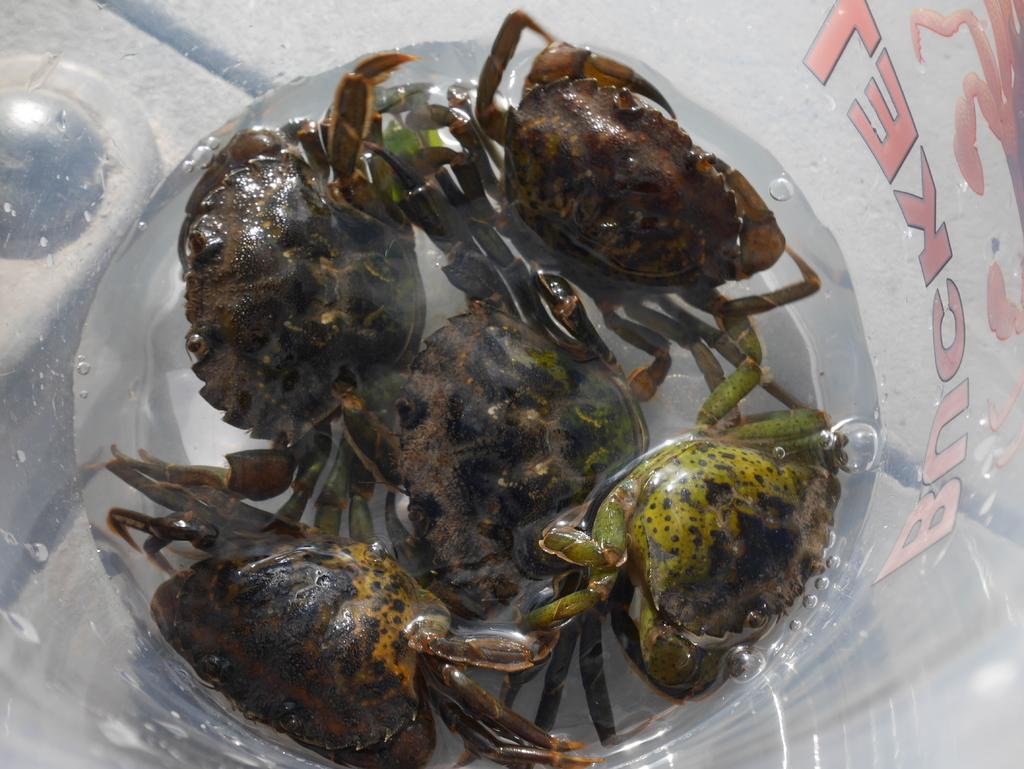What type of animals are present in the image? There are crabs in the image. What is the distance between the crabs and the space station in the image? There is no space station present in the image, as it only features crabs. 